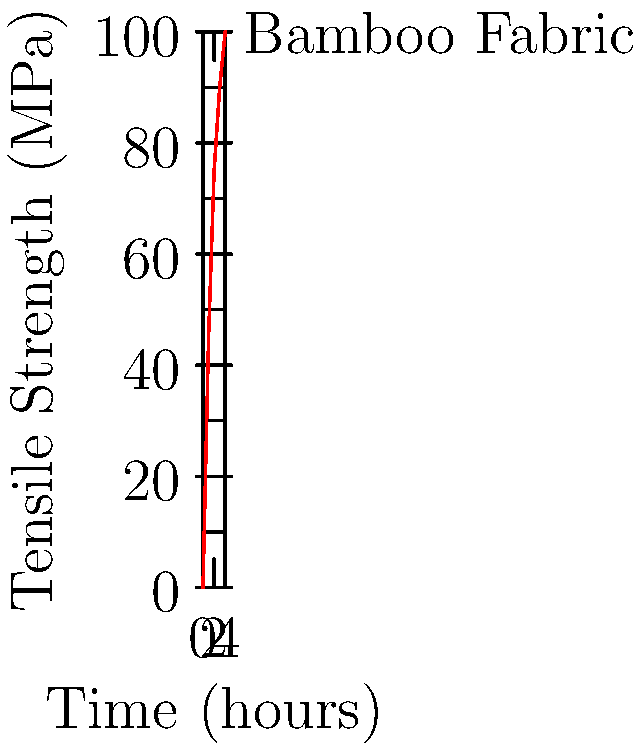In the context of sustainable fashion, the graph shows the tensile strength development of bamboo fabric over time during a treatment process. If a minimum tensile strength of 80 MPa is required for a new eco-friendly clothing line, how many hours of treatment are necessary to achieve this strength? To determine the treatment time required to achieve a tensile strength of 80 MPa for the bamboo fabric, we need to analyze the graph step-by-step:

1. Identify the target tensile strength: 80 MPa

2. Examine the graph:
   - The x-axis represents time in hours
   - The y-axis represents tensile strength in MPa
   - The red line shows the relationship between treatment time and tensile strength

3. Trace the 80 MPa mark on the y-axis horizontally until it intersects with the red line

4. From the intersection point, draw a vertical line down to the x-axis

5. The point where this vertical line meets the x-axis indicates the required treatment time

6. Reading from the graph, we can see that the 80 MPa mark intersects the red line between 2 and 3 hours

7. More precisely, it appears to be closer to 2.5 hours

Therefore, approximately 2.5 hours of treatment are necessary to achieve the required tensile strength of 80 MPa for the bamboo fabric.
Answer: 2.5 hours 